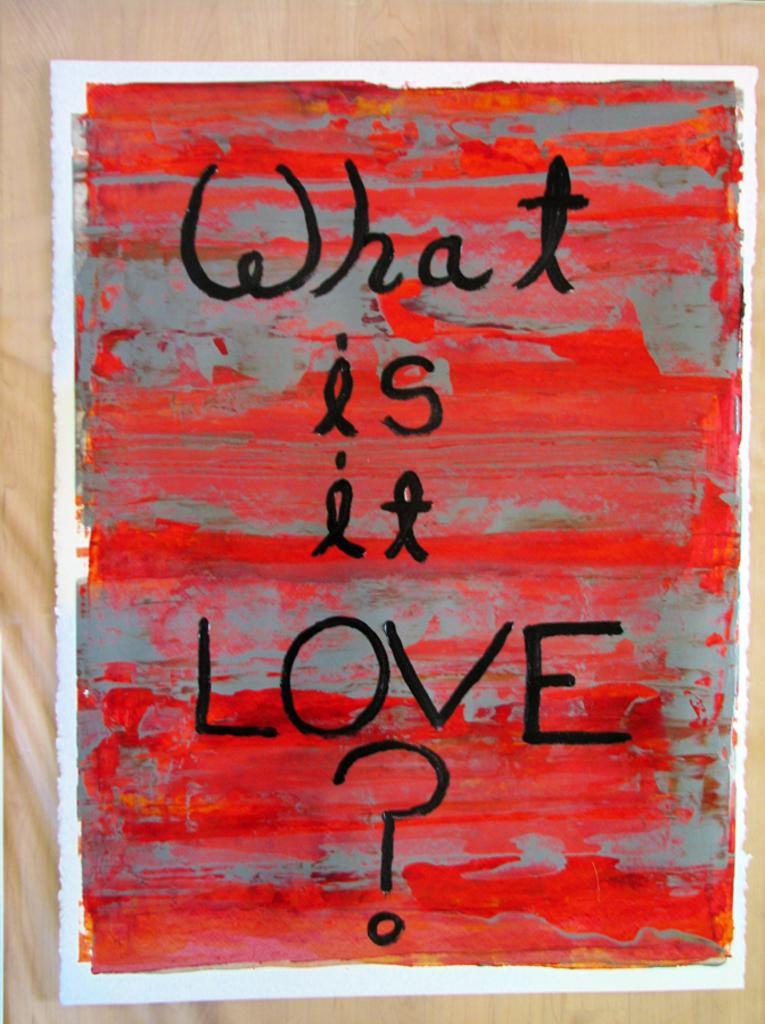<image>
Provide a brief description of the given image. A poster in red and gray that is titled What Is It Love. 